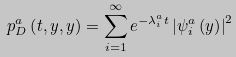<formula> <loc_0><loc_0><loc_500><loc_500>p _ { D } ^ { a } \left ( t , y , y \right ) = \sum _ { i = 1 } ^ { \infty } e ^ { - \lambda _ { i } ^ { a } t } \left | \psi _ { i } ^ { a } \left ( y \right ) \right | ^ { 2 }</formula> 